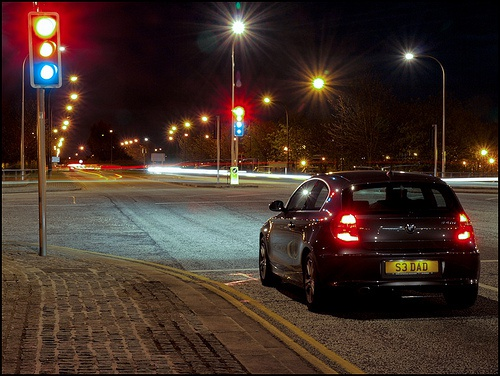Describe the objects in this image and their specific colors. I can see car in black, maroon, gray, and brown tones, traffic light in black, white, lightblue, and red tones, and traffic light in black, white, lightblue, lime, and darkgray tones in this image. 